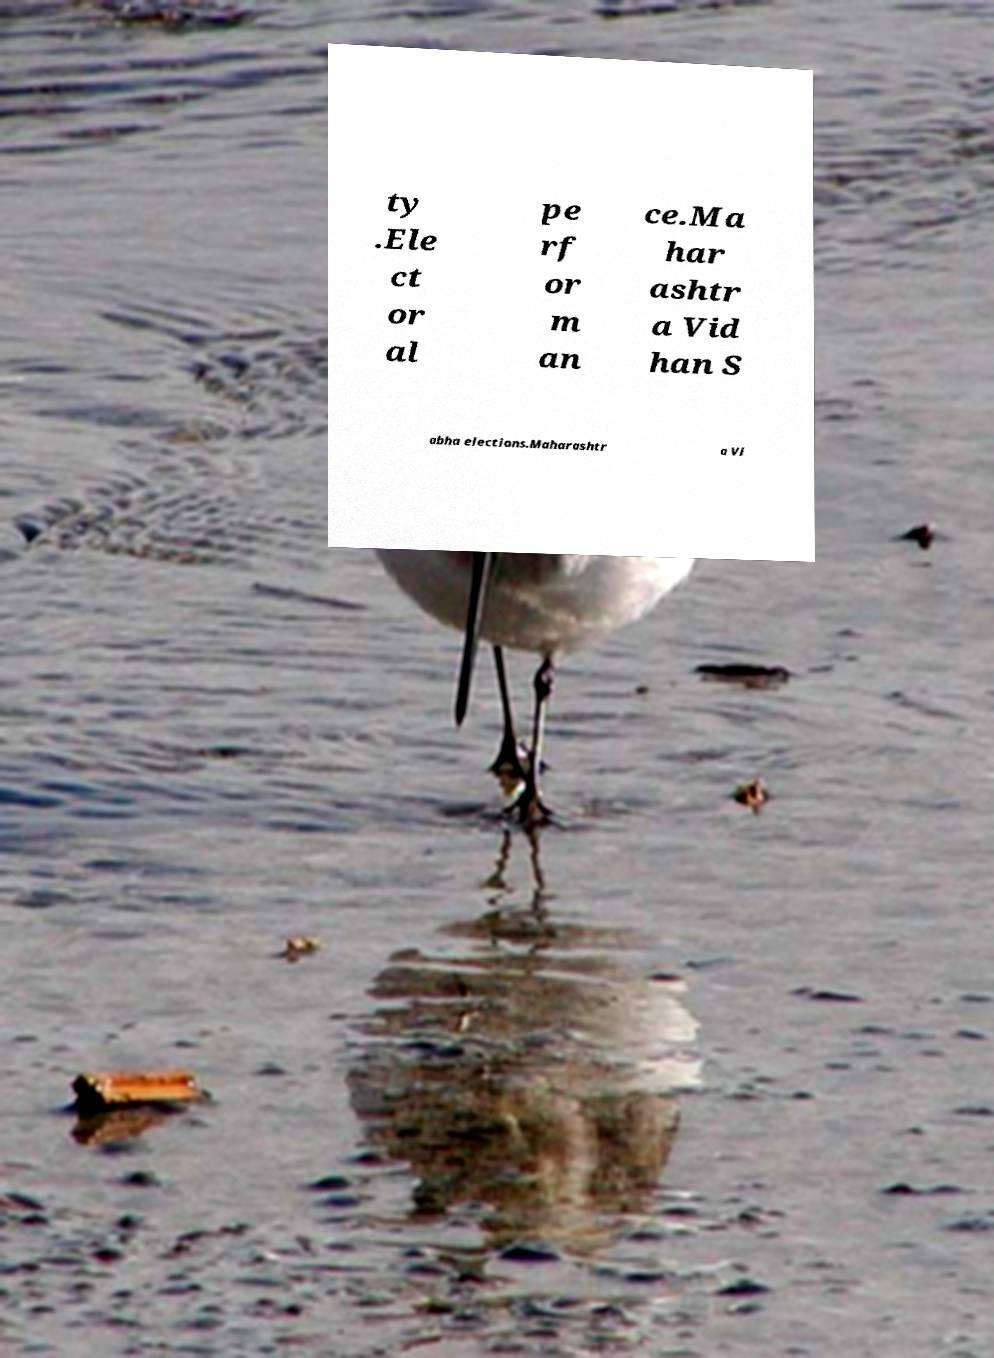Could you assist in decoding the text presented in this image and type it out clearly? ty .Ele ct or al pe rf or m an ce.Ma har ashtr a Vid han S abha elections.Maharashtr a Vi 